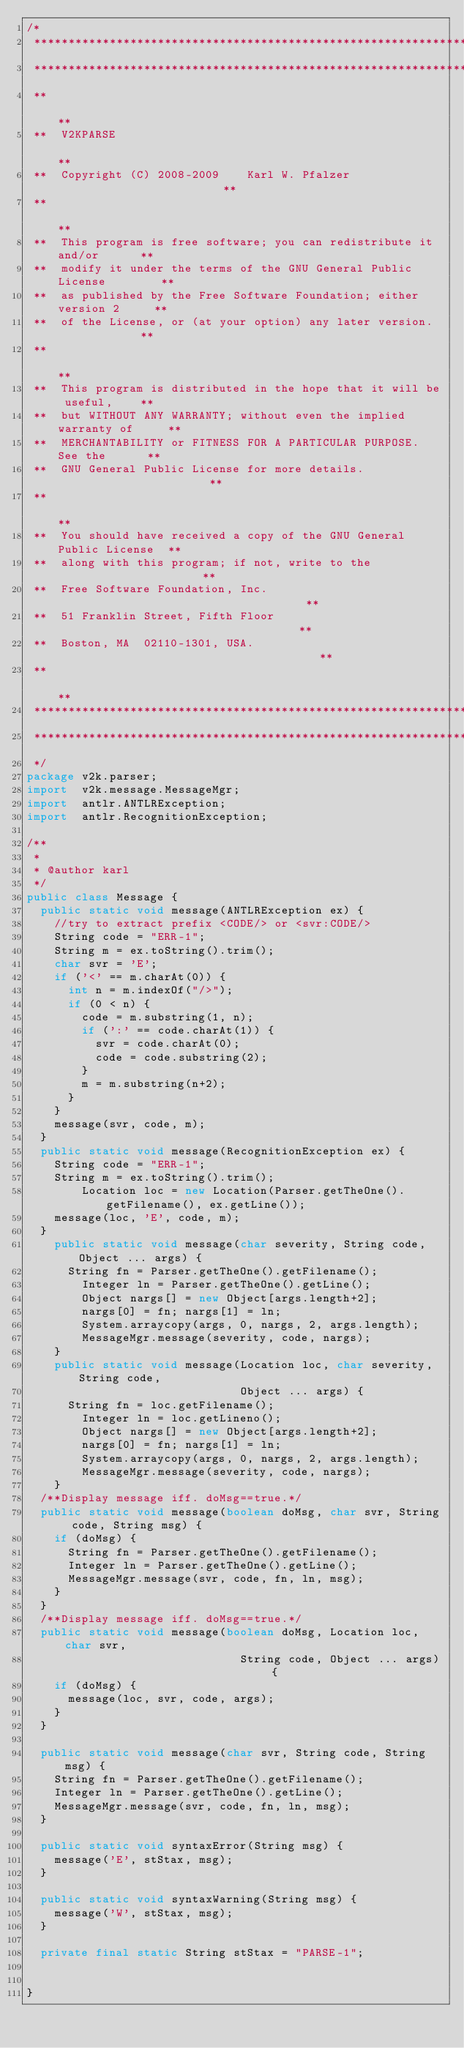Convert code to text. <code><loc_0><loc_0><loc_500><loc_500><_Java_>/*
 *************************************************************************
 *************************************************************************
 **                                                                     **
 **  V2KPARSE                                                           **
 **  Copyright (C) 2008-2009    Karl W. Pfalzer                         **
 **                                                                     **
 **  This program is free software; you can redistribute it and/or      **
 **  modify it under the terms of the GNU General Public License        **
 **  as published by the Free Software Foundation; either version 2     **
 **  of the License, or (at your option) any later version.             **
 **                                                                     **
 **  This program is distributed in the hope that it will be useful,    **
 **  but WITHOUT ANY WARRANTY; without even the implied warranty of     **
 **  MERCHANTABILITY or FITNESS FOR A PARTICULAR PURPOSE.  See the      **
 **  GNU General Public License for more details.                       **
 **                                                                     **
 **  You should have received a copy of the GNU General Public License  **
 **  along with this program; if not, write to the                      **
 **  Free Software Foundation, Inc.                                     **
 **  51 Franklin Street, Fifth Floor                                    **
 **  Boston, MA  02110-1301, USA.                                       **
 **                                                                     **
 *************************************************************************
 *************************************************************************
 */
package v2k.parser;
import  v2k.message.MessageMgr;
import	antlr.ANTLRException;
import  antlr.RecognitionException;

/**
 *
 * @author karl
 */
public class Message {
	public static void message(ANTLRException ex) {
		//try to extract prefix <CODE/> or <svr:CODE/>
		String code = "ERR-1";
		String m = ex.toString().trim();
		char svr = 'E';
		if ('<' == m.charAt(0)) {
			int n = m.indexOf("/>");
			if (0 < n) {
				code = m.substring(1, n);
				if (':' == code.charAt(1)) {
					svr = code.charAt(0);
					code = code.substring(2);
				}
				m = m.substring(n+2);
			}
		}
		message(svr, code, m);
	}
	public static void message(RecognitionException ex) {
		String code = "ERR-1";
		String m = ex.toString().trim();
        Location loc = new Location(Parser.getTheOne().getFilename(), ex.getLine());
		message(loc, 'E', code, m);
	}
    public static void message(char severity, String code, Object ... args) {
   		String fn = Parser.getTheOne().getFilename();
       	Integer ln = Parser.getTheOne().getLine();
        Object nargs[] = new Object[args.length+2];
        nargs[0] = fn; nargs[1] = ln;
        System.arraycopy(args, 0, nargs, 2, args.length);
        MessageMgr.message(severity, code, nargs);
    }
    public static void message(Location loc, char severity, String code, 
                               Object ... args) {
   		String fn = loc.getFilename();
       	Integer ln = loc.getLineno();
        Object nargs[] = new Object[args.length+2];
        nargs[0] = fn; nargs[1] = ln;
        System.arraycopy(args, 0, nargs, 2, args.length);
        MessageMgr.message(severity, code, nargs);
    }
	/**Display message iff. doMsg==true.*/
	public static void message(boolean doMsg, char svr, String code, String msg) {
		if (doMsg) {
			String fn = Parser.getTheOne().getFilename();
			Integer ln = Parser.getTheOne().getLine();
			MessageMgr.message(svr, code, fn, ln, msg);
		}
	}
	/**Display message iff. doMsg==true.*/
	public static void message(boolean doMsg, Location loc, char svr, 
                               String code, Object ... args) {
		if (doMsg) {
			message(loc, svr, code, args);
		}
	}

	public static void message(char svr, String code, String msg) {
		String fn = Parser.getTheOne().getFilename();
		Integer ln = Parser.getTheOne().getLine();
		MessageMgr.message(svr, code, fn, ln, msg);
	}
	
	public static void syntaxError(String msg) {
		message('E', stStax, msg);
	}

	public static void syntaxWarning(String msg) {
		message('W', stStax, msg);
	}

	private final static String stStax = "PARSE-1";
	

}
</code> 